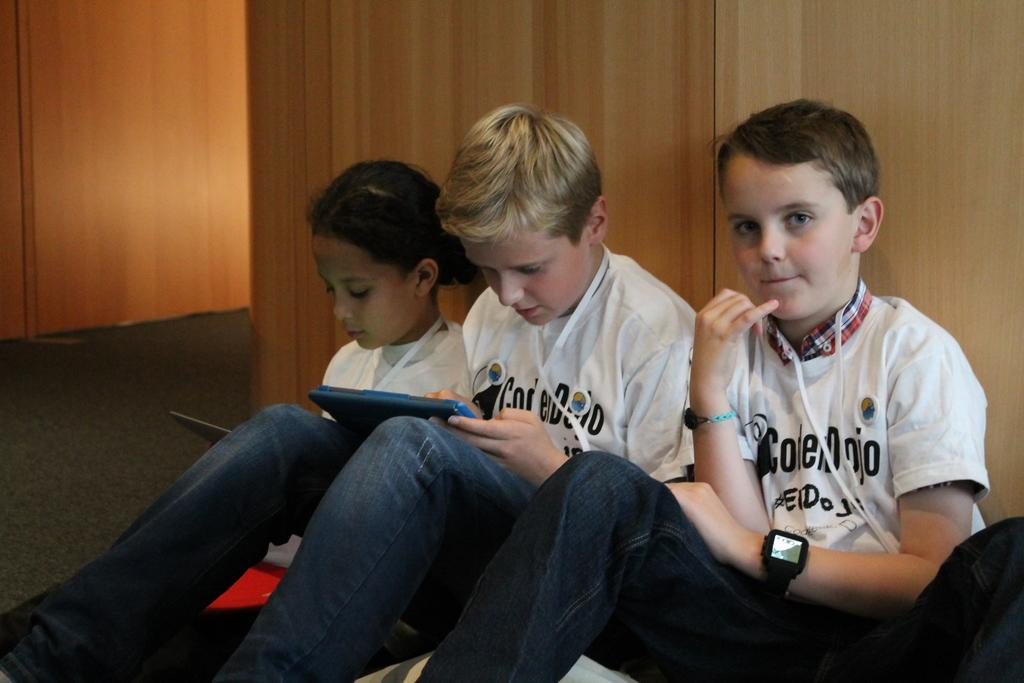How many kids are in the image? There are kids in the image. What are the kids wearing? The kids are wearing clothes. What is behind the kids in the image? The kids are sitting in front of a wooden wall. Can you describe the position of the kids in the image? There is a kid in the middle of the image, and the other kids are sitting around him. What is the kid in the middle holding? The kid in the middle is holding an object with his hand. Is there a bridge visible in the image? No, there is no bridge present in the image. What type of whistle can be heard in the background of the image? There is no whistle sound in the image, as it is a still photograph. 